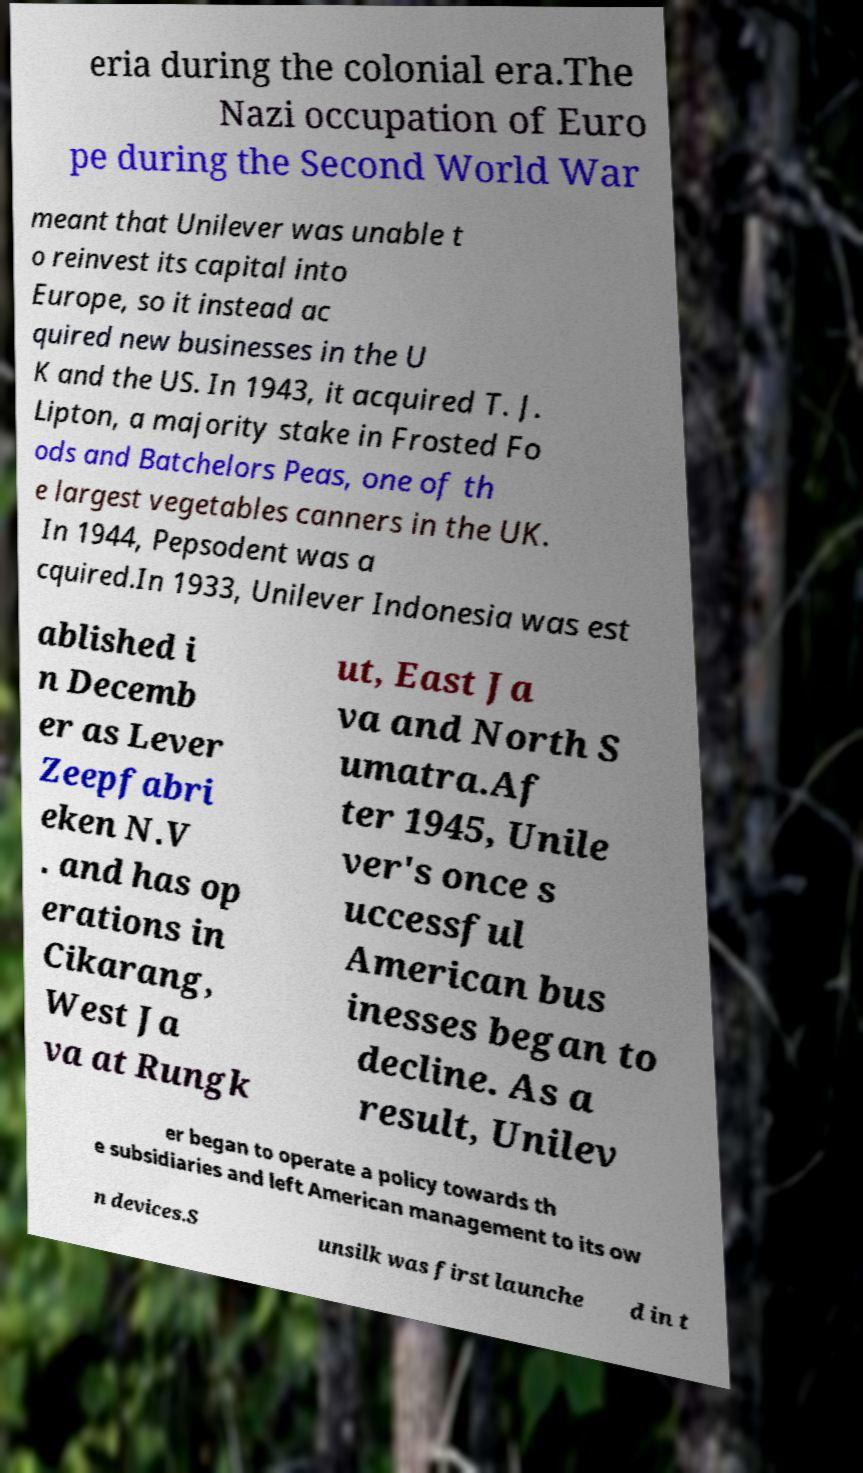I need the written content from this picture converted into text. Can you do that? eria during the colonial era.The Nazi occupation of Euro pe during the Second World War meant that Unilever was unable t o reinvest its capital into Europe, so it instead ac quired new businesses in the U K and the US. In 1943, it acquired T. J. Lipton, a majority stake in Frosted Fo ods and Batchelors Peas, one of th e largest vegetables canners in the UK. In 1944, Pepsodent was a cquired.In 1933, Unilever Indonesia was est ablished i n Decemb er as Lever Zeepfabri eken N.V . and has op erations in Cikarang, West Ja va at Rungk ut, East Ja va and North S umatra.Af ter 1945, Unile ver's once s uccessful American bus inesses began to decline. As a result, Unilev er began to operate a policy towards th e subsidiaries and left American management to its ow n devices.S unsilk was first launche d in t 